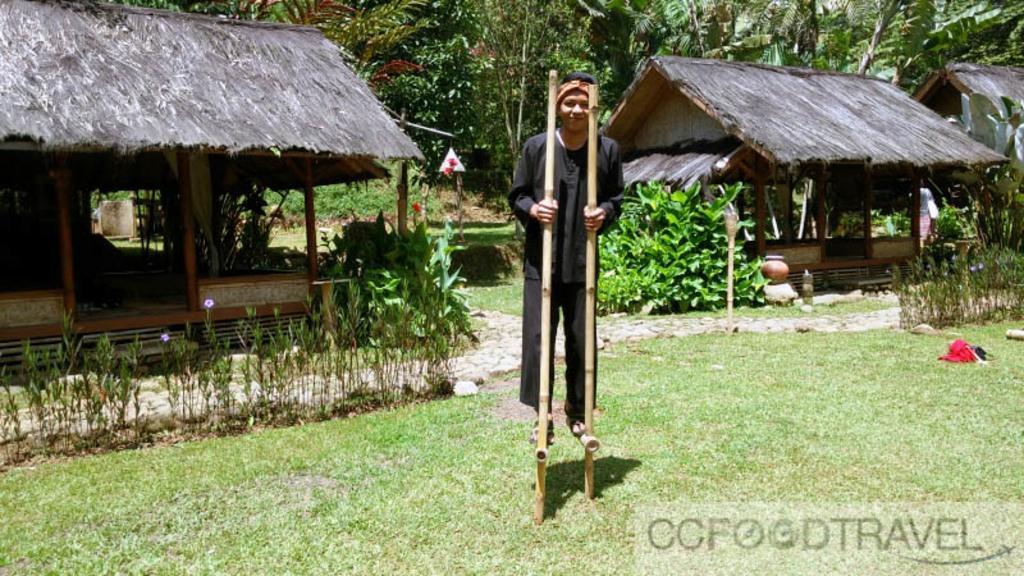Describe this image in one or two sentences. In this image we can see a person standing on the sticks above the ground. In the background we can see thatched houses, trees, pots, plants and bushes. 